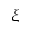<formula> <loc_0><loc_0><loc_500><loc_500>\xi</formula> 